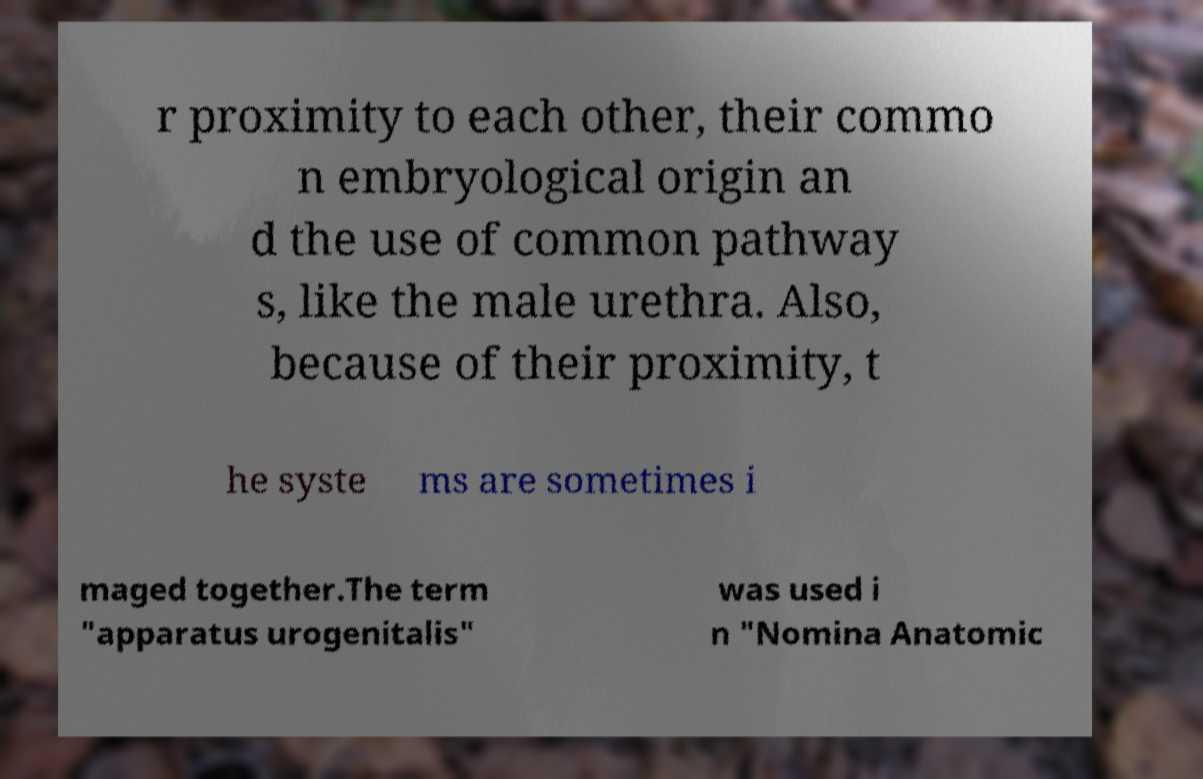Please identify and transcribe the text found in this image. r proximity to each other, their commo n embryological origin an d the use of common pathway s, like the male urethra. Also, because of their proximity, t he syste ms are sometimes i maged together.The term "apparatus urogenitalis" was used i n "Nomina Anatomic 